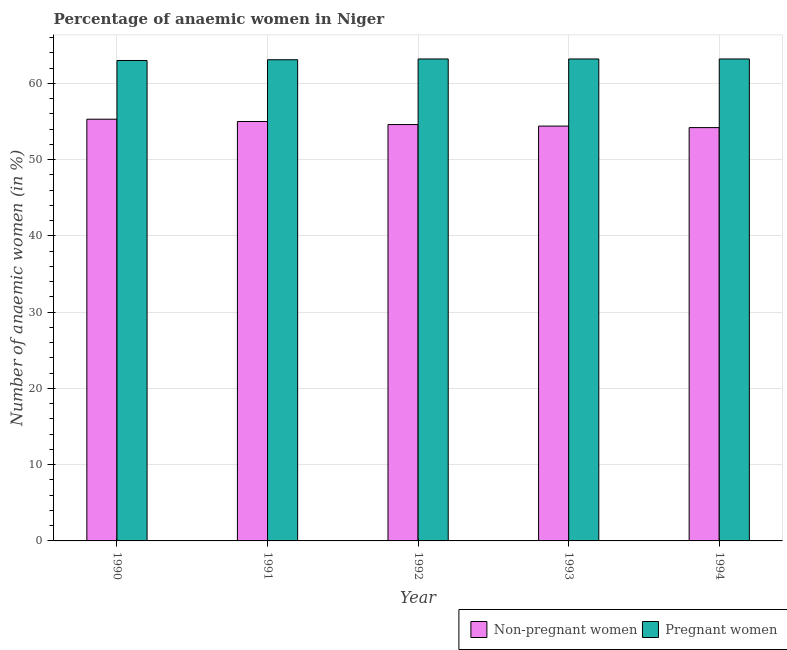Are the number of bars per tick equal to the number of legend labels?
Make the answer very short. Yes. What is the percentage of pregnant anaemic women in 1994?
Make the answer very short. 63.2. Across all years, what is the maximum percentage of non-pregnant anaemic women?
Offer a very short reply. 55.3. Across all years, what is the minimum percentage of non-pregnant anaemic women?
Your response must be concise. 54.2. In which year was the percentage of pregnant anaemic women maximum?
Offer a terse response. 1992. What is the total percentage of non-pregnant anaemic women in the graph?
Offer a very short reply. 273.5. What is the difference between the percentage of non-pregnant anaemic women in 1991 and that in 1992?
Ensure brevity in your answer.  0.4. What is the difference between the percentage of non-pregnant anaemic women in 1990 and the percentage of pregnant anaemic women in 1993?
Offer a very short reply. 0.9. What is the average percentage of non-pregnant anaemic women per year?
Your answer should be very brief. 54.7. Is the difference between the percentage of pregnant anaemic women in 1990 and 1991 greater than the difference between the percentage of non-pregnant anaemic women in 1990 and 1991?
Your answer should be very brief. No. What is the difference between the highest and the second highest percentage of pregnant anaemic women?
Offer a very short reply. 0. What is the difference between the highest and the lowest percentage of non-pregnant anaemic women?
Give a very brief answer. 1.1. In how many years, is the percentage of pregnant anaemic women greater than the average percentage of pregnant anaemic women taken over all years?
Keep it short and to the point. 3. What does the 1st bar from the left in 1990 represents?
Provide a succinct answer. Non-pregnant women. What does the 2nd bar from the right in 1994 represents?
Your response must be concise. Non-pregnant women. Are all the bars in the graph horizontal?
Your answer should be compact. No. How many years are there in the graph?
Make the answer very short. 5. Does the graph contain grids?
Provide a succinct answer. Yes. Where does the legend appear in the graph?
Provide a succinct answer. Bottom right. How many legend labels are there?
Offer a terse response. 2. What is the title of the graph?
Offer a terse response. Percentage of anaemic women in Niger. Does "Health Care" appear as one of the legend labels in the graph?
Give a very brief answer. No. What is the label or title of the Y-axis?
Give a very brief answer. Number of anaemic women (in %). What is the Number of anaemic women (in %) in Non-pregnant women in 1990?
Provide a succinct answer. 55.3. What is the Number of anaemic women (in %) of Non-pregnant women in 1991?
Keep it short and to the point. 55. What is the Number of anaemic women (in %) in Pregnant women in 1991?
Ensure brevity in your answer.  63.1. What is the Number of anaemic women (in %) in Non-pregnant women in 1992?
Your answer should be very brief. 54.6. What is the Number of anaemic women (in %) in Pregnant women in 1992?
Provide a short and direct response. 63.2. What is the Number of anaemic women (in %) of Non-pregnant women in 1993?
Make the answer very short. 54.4. What is the Number of anaemic women (in %) of Pregnant women in 1993?
Give a very brief answer. 63.2. What is the Number of anaemic women (in %) in Non-pregnant women in 1994?
Provide a short and direct response. 54.2. What is the Number of anaemic women (in %) of Pregnant women in 1994?
Ensure brevity in your answer.  63.2. Across all years, what is the maximum Number of anaemic women (in %) in Non-pregnant women?
Make the answer very short. 55.3. Across all years, what is the maximum Number of anaemic women (in %) of Pregnant women?
Give a very brief answer. 63.2. Across all years, what is the minimum Number of anaemic women (in %) of Non-pregnant women?
Offer a terse response. 54.2. Across all years, what is the minimum Number of anaemic women (in %) of Pregnant women?
Provide a short and direct response. 63. What is the total Number of anaemic women (in %) of Non-pregnant women in the graph?
Give a very brief answer. 273.5. What is the total Number of anaemic women (in %) in Pregnant women in the graph?
Ensure brevity in your answer.  315.7. What is the difference between the Number of anaemic women (in %) in Non-pregnant women in 1990 and that in 1991?
Give a very brief answer. 0.3. What is the difference between the Number of anaemic women (in %) of Pregnant women in 1990 and that in 1992?
Make the answer very short. -0.2. What is the difference between the Number of anaemic women (in %) in Non-pregnant women in 1990 and that in 1993?
Give a very brief answer. 0.9. What is the difference between the Number of anaemic women (in %) of Non-pregnant women in 1990 and that in 1994?
Give a very brief answer. 1.1. What is the difference between the Number of anaemic women (in %) in Pregnant women in 1991 and that in 1992?
Give a very brief answer. -0.1. What is the difference between the Number of anaemic women (in %) of Pregnant women in 1991 and that in 1993?
Give a very brief answer. -0.1. What is the difference between the Number of anaemic women (in %) of Non-pregnant women in 1992 and that in 1994?
Make the answer very short. 0.4. What is the difference between the Number of anaemic women (in %) in Non-pregnant women in 1990 and the Number of anaemic women (in %) in Pregnant women in 1991?
Your answer should be very brief. -7.8. What is the difference between the Number of anaemic women (in %) of Non-pregnant women in 1990 and the Number of anaemic women (in %) of Pregnant women in 1992?
Give a very brief answer. -7.9. What is the difference between the Number of anaemic women (in %) in Non-pregnant women in 1990 and the Number of anaemic women (in %) in Pregnant women in 1993?
Offer a terse response. -7.9. What is the difference between the Number of anaemic women (in %) of Non-pregnant women in 1990 and the Number of anaemic women (in %) of Pregnant women in 1994?
Keep it short and to the point. -7.9. What is the difference between the Number of anaemic women (in %) of Non-pregnant women in 1991 and the Number of anaemic women (in %) of Pregnant women in 1992?
Offer a terse response. -8.2. What is the difference between the Number of anaemic women (in %) of Non-pregnant women in 1991 and the Number of anaemic women (in %) of Pregnant women in 1993?
Your response must be concise. -8.2. What is the difference between the Number of anaemic women (in %) in Non-pregnant women in 1991 and the Number of anaemic women (in %) in Pregnant women in 1994?
Offer a terse response. -8.2. What is the difference between the Number of anaemic women (in %) in Non-pregnant women in 1993 and the Number of anaemic women (in %) in Pregnant women in 1994?
Provide a short and direct response. -8.8. What is the average Number of anaemic women (in %) in Non-pregnant women per year?
Give a very brief answer. 54.7. What is the average Number of anaemic women (in %) in Pregnant women per year?
Offer a terse response. 63.14. In the year 1990, what is the difference between the Number of anaemic women (in %) of Non-pregnant women and Number of anaemic women (in %) of Pregnant women?
Your answer should be very brief. -7.7. In the year 1991, what is the difference between the Number of anaemic women (in %) of Non-pregnant women and Number of anaemic women (in %) of Pregnant women?
Provide a short and direct response. -8.1. In the year 1992, what is the difference between the Number of anaemic women (in %) in Non-pregnant women and Number of anaemic women (in %) in Pregnant women?
Provide a short and direct response. -8.6. In the year 1994, what is the difference between the Number of anaemic women (in %) in Non-pregnant women and Number of anaemic women (in %) in Pregnant women?
Give a very brief answer. -9. What is the ratio of the Number of anaemic women (in %) of Pregnant women in 1990 to that in 1991?
Keep it short and to the point. 1. What is the ratio of the Number of anaemic women (in %) of Non-pregnant women in 1990 to that in 1992?
Offer a terse response. 1.01. What is the ratio of the Number of anaemic women (in %) in Non-pregnant women in 1990 to that in 1993?
Keep it short and to the point. 1.02. What is the ratio of the Number of anaemic women (in %) in Non-pregnant women in 1990 to that in 1994?
Your response must be concise. 1.02. What is the ratio of the Number of anaemic women (in %) in Pregnant women in 1990 to that in 1994?
Your answer should be compact. 1. What is the ratio of the Number of anaemic women (in %) of Non-pregnant women in 1991 to that in 1992?
Keep it short and to the point. 1.01. What is the ratio of the Number of anaemic women (in %) in Non-pregnant women in 1991 to that in 1993?
Your answer should be compact. 1.01. What is the ratio of the Number of anaemic women (in %) of Pregnant women in 1991 to that in 1993?
Provide a short and direct response. 1. What is the ratio of the Number of anaemic women (in %) in Non-pregnant women in 1991 to that in 1994?
Offer a terse response. 1.01. What is the ratio of the Number of anaemic women (in %) of Pregnant women in 1991 to that in 1994?
Provide a succinct answer. 1. What is the ratio of the Number of anaemic women (in %) of Pregnant women in 1992 to that in 1993?
Your answer should be very brief. 1. What is the ratio of the Number of anaemic women (in %) in Non-pregnant women in 1992 to that in 1994?
Offer a terse response. 1.01. What is the ratio of the Number of anaemic women (in %) of Pregnant women in 1993 to that in 1994?
Offer a very short reply. 1. What is the difference between the highest and the lowest Number of anaemic women (in %) in Non-pregnant women?
Ensure brevity in your answer.  1.1. What is the difference between the highest and the lowest Number of anaemic women (in %) of Pregnant women?
Give a very brief answer. 0.2. 